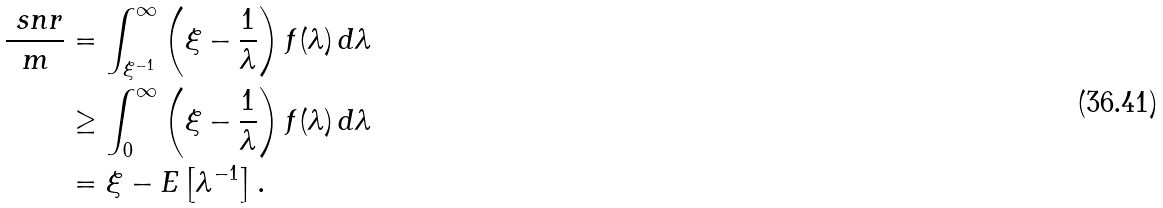<formula> <loc_0><loc_0><loc_500><loc_500>\frac { \ s n r } { m } & = \int _ { \xi ^ { - 1 } } ^ { \infty } \left ( \xi - \frac { 1 } { \lambda } \right ) f ( \lambda ) \, d \lambda \\ & \geq \int _ { 0 } ^ { \infty } \left ( \xi - \frac { 1 } { \lambda } \right ) f ( \lambda ) \, d \lambda \\ & = \xi - E \left [ \lambda ^ { - 1 } \right ] .</formula> 